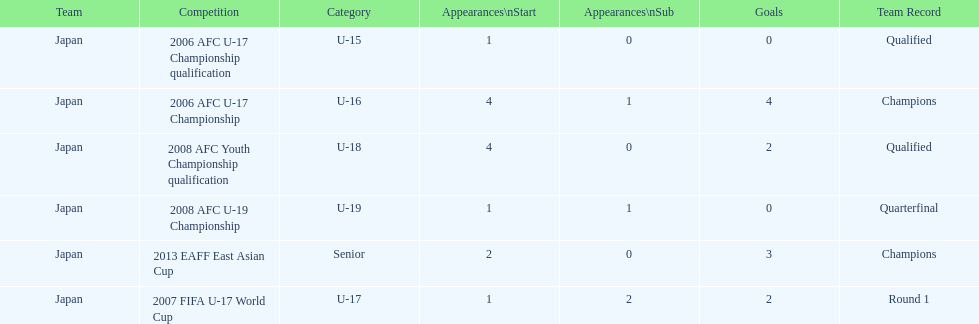Where did japan only score four goals? 2006 AFC U-17 Championship. 